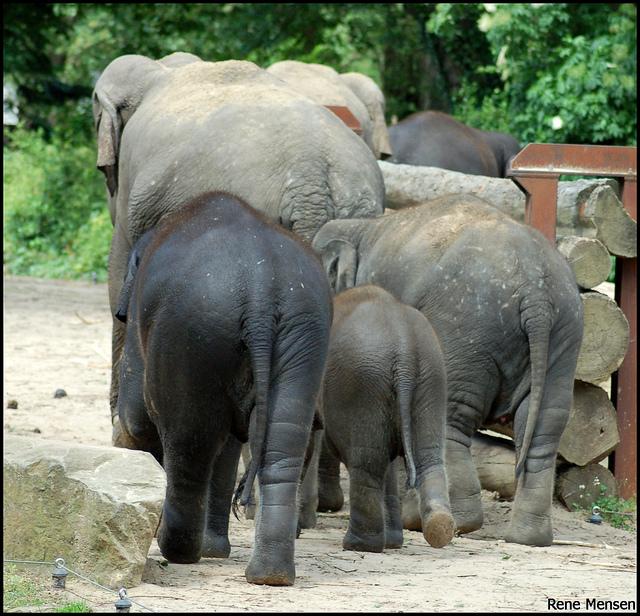Is this a baby elephant?
Write a very short answer. Yes. How many elephants are there?
Short answer required. 5. What are the elephants doing?
Short answer required. Walking. Are the elephants all facing the same direction?
Answer briefly. Yes. Are the elephants all the same age?
Concise answer only. No. How many elephants are in this picture?
Keep it brief. 6. Are there any logs in the picture?
Answer briefly. Yes. Are these elephants facing the camera?
Answer briefly. No. 